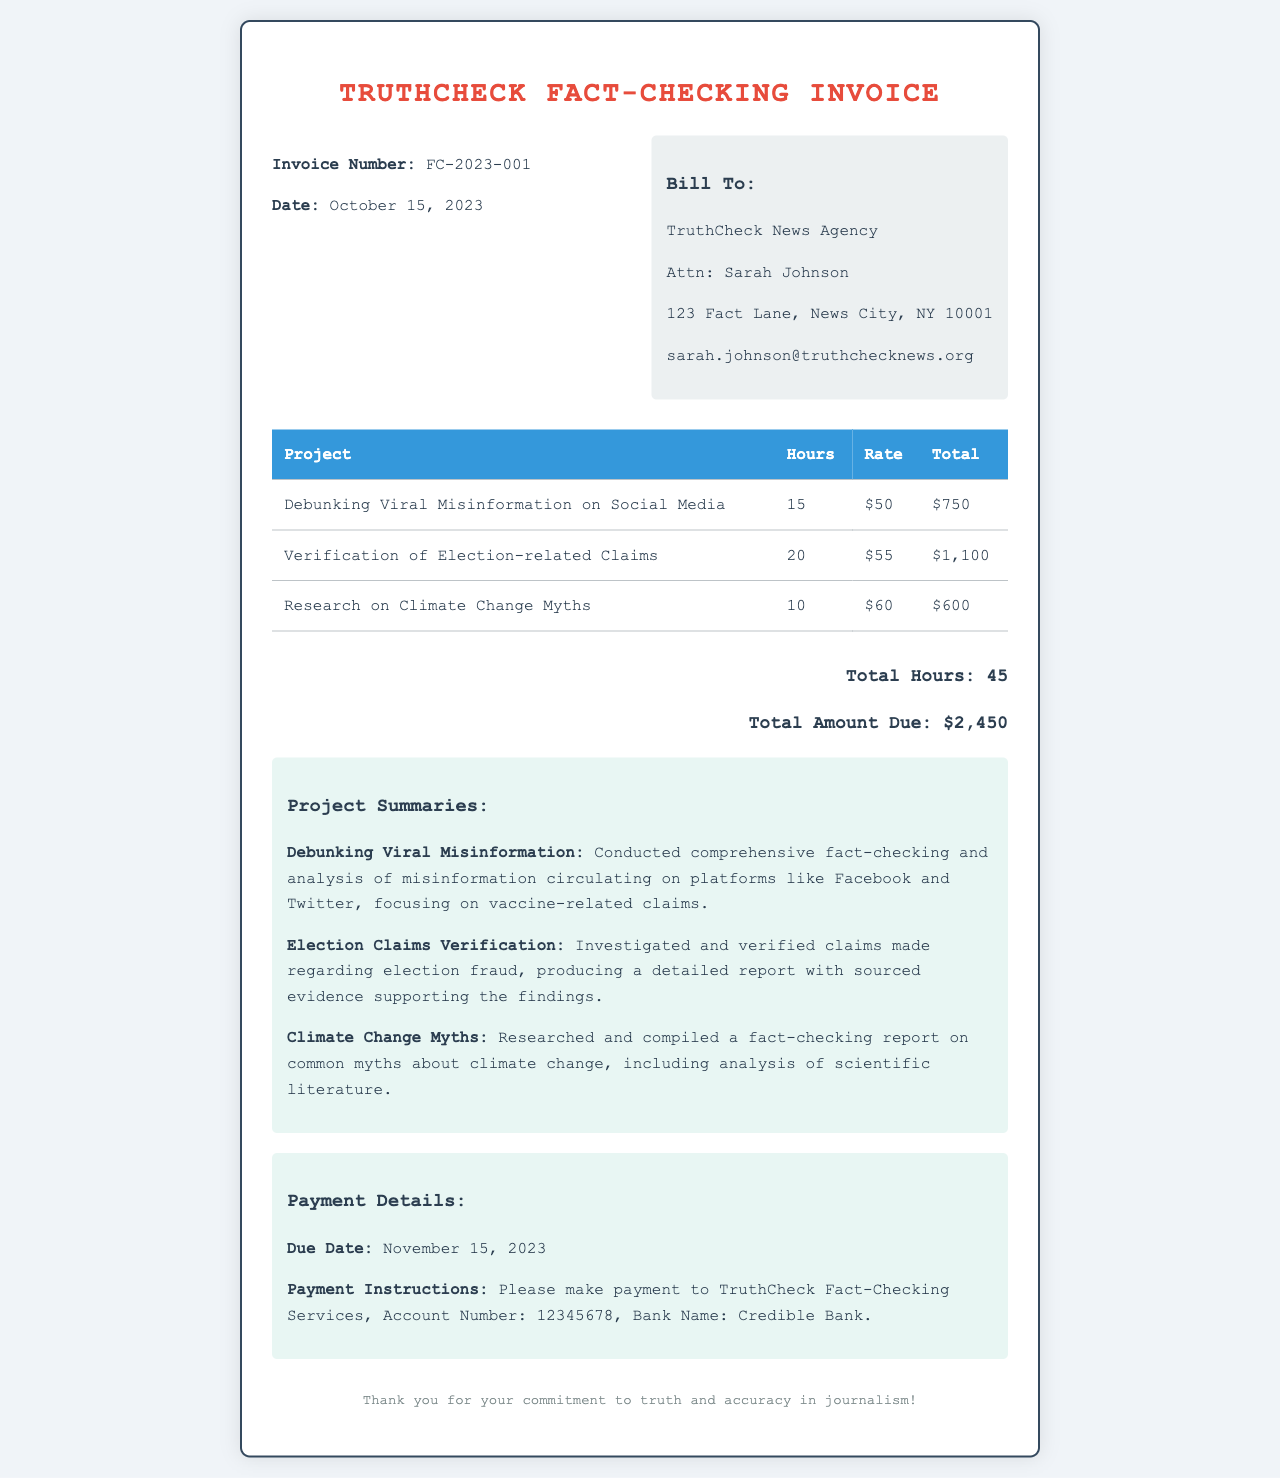What is the invoice number? The invoice number is specified at the top of the document, indicating the unique identifier for this invoice.
Answer: FC-2023-001 What is the total amount due? The total amount due is found in the total section of the invoice, summarizing the services rendered.
Answer: $2,450 Who is the contact person for the billing? The billing section indicates the name of the contact person associated with the news agency for this invoice.
Answer: Sarah Johnson How many hours were billed for verification of election-related claims? The hours billed can be found in the table under the respective project heading for verification of election-related claims.
Answer: 20 What was the hourly rate for research on climate change myths? The hourly rate is specified in the table corresponding to the specific project, indicating the cost per hour for services rendered.
Answer: $60 What is the due date for payment? The payment details section specifies the due date for making the total payment according to the invoice.
Answer: November 15, 2023 What type of document is this? The overall structure and content indicate that this document is a formal invoice detailing services provided.
Answer: Invoice How many total projects are listed in the table? The count of projects is found in the table section, which lists individual projects alongside their billed hours and totals.
Answer: 3 What is the highest hourly rate charged for services? The rates for each project are specified, with the highest rate identified in the table for the service provided.
Answer: $60 